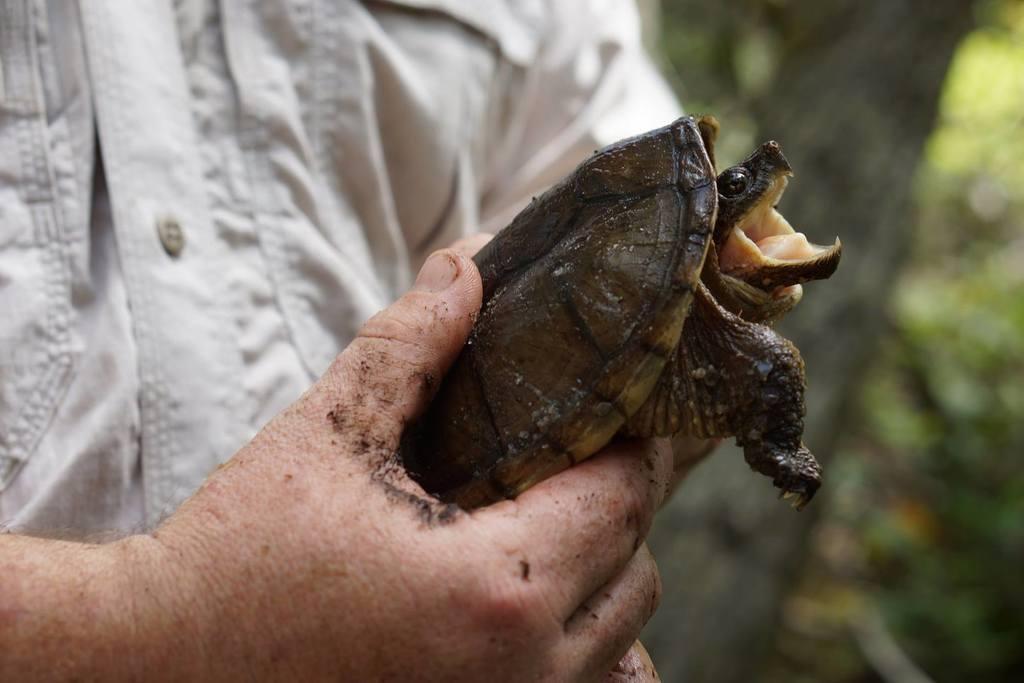Can you describe this image briefly? In this picture, we see the man in the grey shirt is holding a turtle in his hands. It is opening its mouth. In the background, we see the trees. This picture is blurred in the background. 